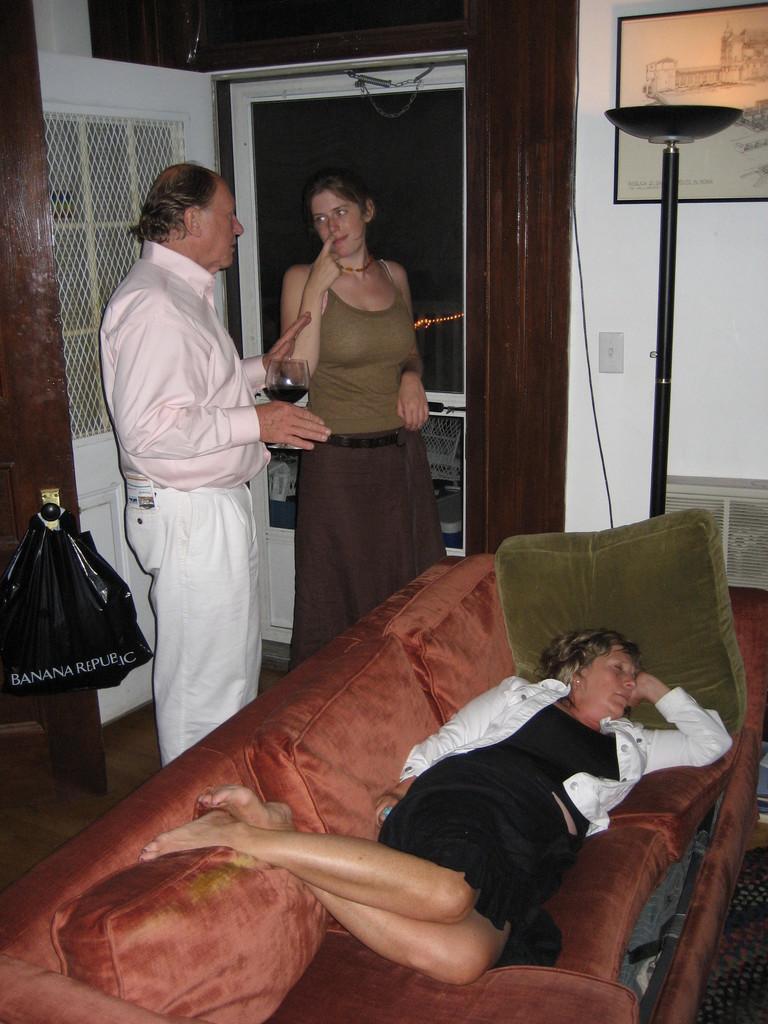Describe this image in one or two sentences. As we can see in the image there is a white color wall, photo frame, three people and sofa. On sofa there is a woman wearing black color dress and sleeping. 